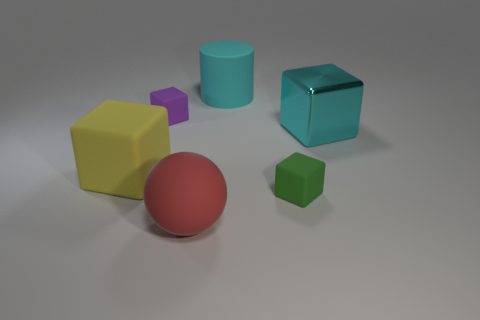Subtract all blue blocks. Subtract all purple spheres. How many blocks are left? 4 Add 3 cyan cylinders. How many objects exist? 9 Subtract all cylinders. How many objects are left? 5 Subtract all big spheres. Subtract all purple things. How many objects are left? 4 Add 3 cyan rubber cylinders. How many cyan rubber cylinders are left? 4 Add 5 shiny objects. How many shiny objects exist? 6 Subtract 1 purple cubes. How many objects are left? 5 